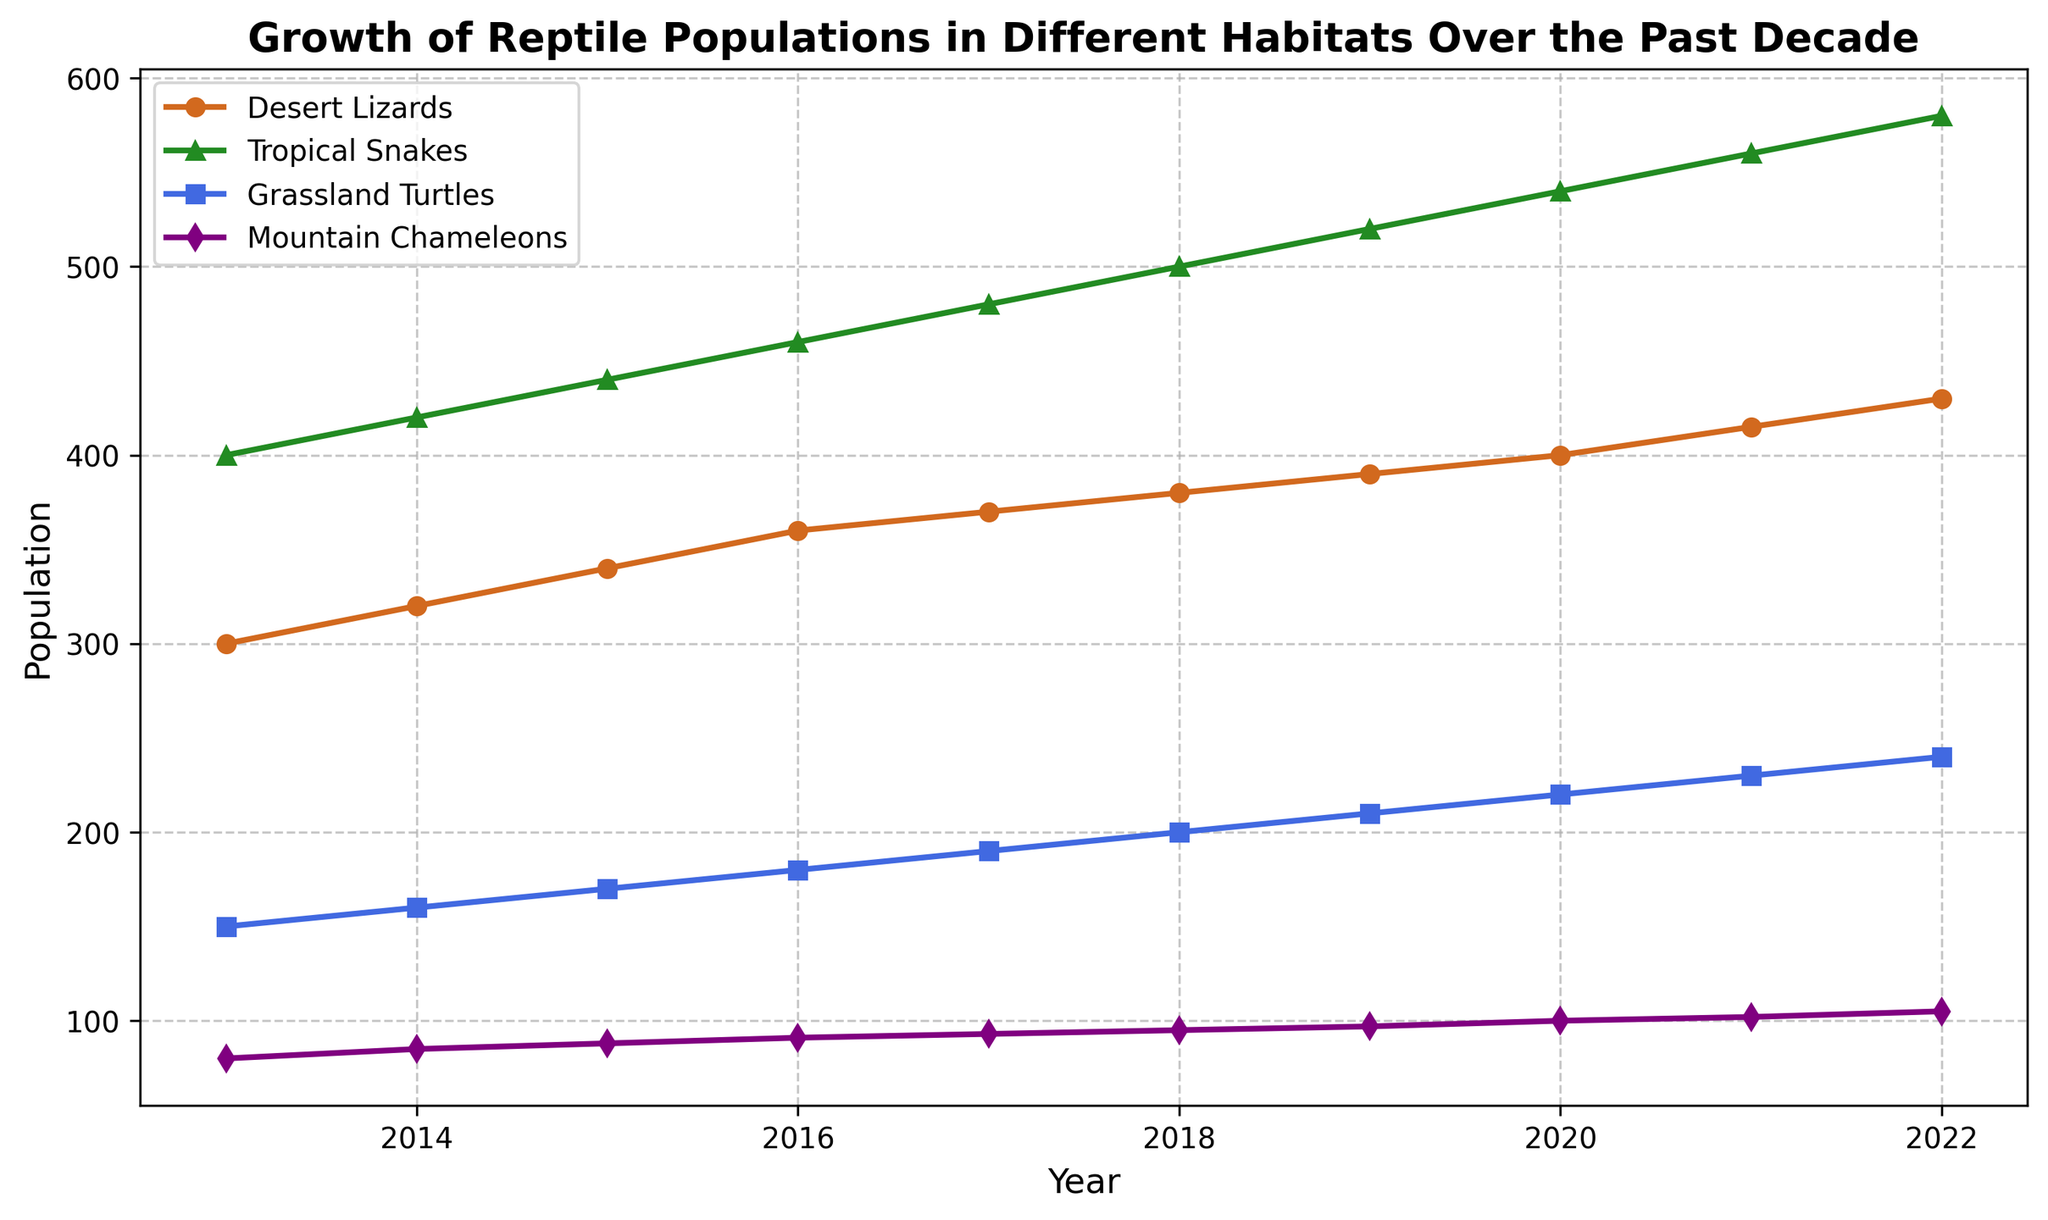Which reptile population had the highest growth from 2013 to 2022? Look at all the lines' endpoints and compare the initial year (2013) and the final year (2022). The Tropical Snakes' population started at 400 and ended at 580, showing the highest increase of 180.
Answer: Tropical Snakes Between which years did Mountain Chameleons have the fastest growth rate? Check the steepness of the line representing Mountain Chameleons. The steepest section is between 2021 and 2022, where the population grows from 102 to 105, the largest yearly increment of 3.
Answer: 2021-2022 What was the population difference between Grassland Turtles and Desert Lizards in 2020? Find the points on both lines representing the year 2020. Grassland Turtles had 220 and Desert Lizards had 400. Difference = 400 - 220 = 180.
Answer: 180 What is the average population of Desert Lizards over the decade? Sum the population values of Desert Lizards from 2013 to 2022 (300 + 320 + 340 + 360 + 370 + 380 + 390 + 400 + 415 + 430) = 3705, then divide by the number of years (10). Average is 3705/10 = 370.5.
Answer: 370.5 In which year did Tropical Snakes first surpass a population of 500? Track the Tropical Snakes line and find the first year where its population exceeds 500. This happens in 2018 (500).
Answer: 2018 How much did the Grassland Turtles population grow from 2015 to 2017? Find the values for Grassland Turtles in 2015 (170) and 2017 (190). Difference = 190 - 170 = 20.
Answer: 20 What is the second highest population among the reptiles in the year 2022? Look at the endpoints for 2022. Tropical Snakes have the highest with 580, followed by Grassland Turtles with 240.
Answer: Grassland Turtles How did the population of Mountain Chameleons change from 2014 to 2022? Identify the population in 2014 (85) and in 2022 (105). Growth = 105 - 85 = 20.
Answer: 20 By how much did the Desert Lizards' population increase between 2016 and 2019? Observe the population values of Desert Lizards in 2016 (360) and 2019 (390). Increase = 390 - 360 = 30.
Answer: 30 